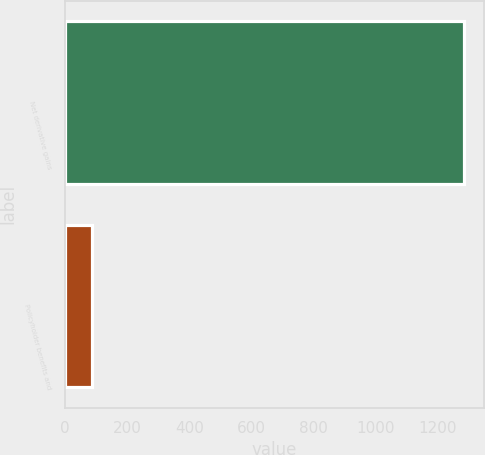<chart> <loc_0><loc_0><loc_500><loc_500><bar_chart><fcel>Net derivative gains<fcel>Policyholder benefits and<nl><fcel>1284<fcel>86<nl></chart> 